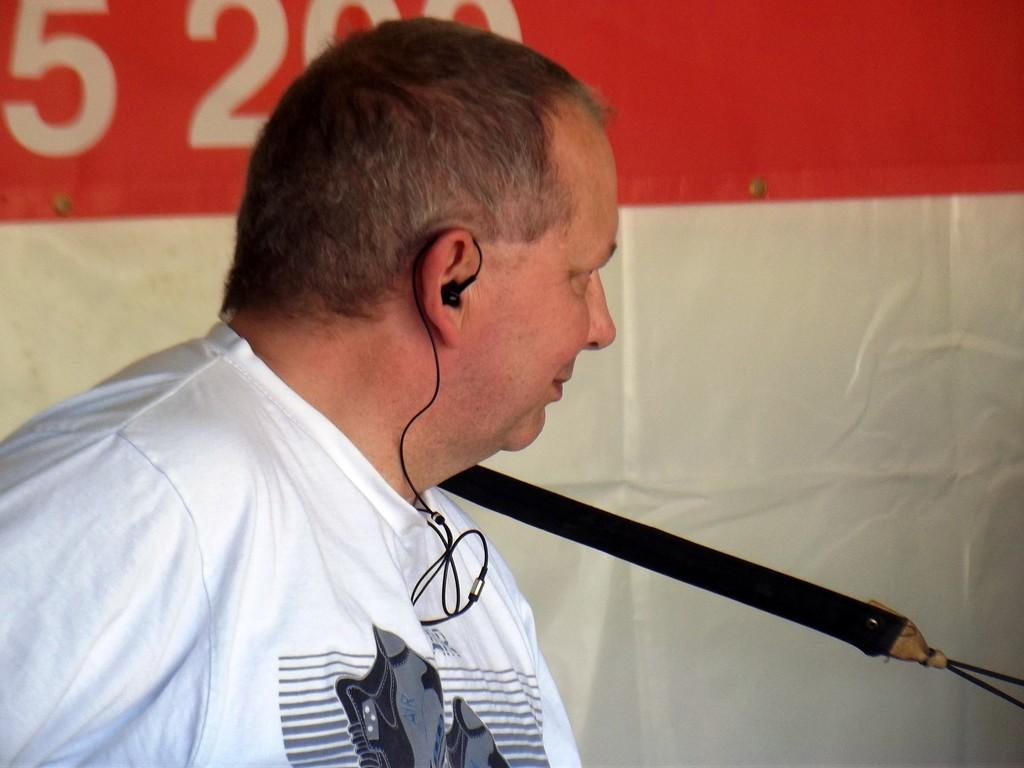What can be seen in the image related to a person? There is a person in the image. What is the person wearing in the image? The person is wearing a headset in the image. What else is present in the image besides the person? There is a banner with numbers and an object beside the person in the image. What type of pies can be seen in the image? There are no pies present in the image. How does the light affect the image? The provided facts do not mention any light source or lighting conditions in the image. 